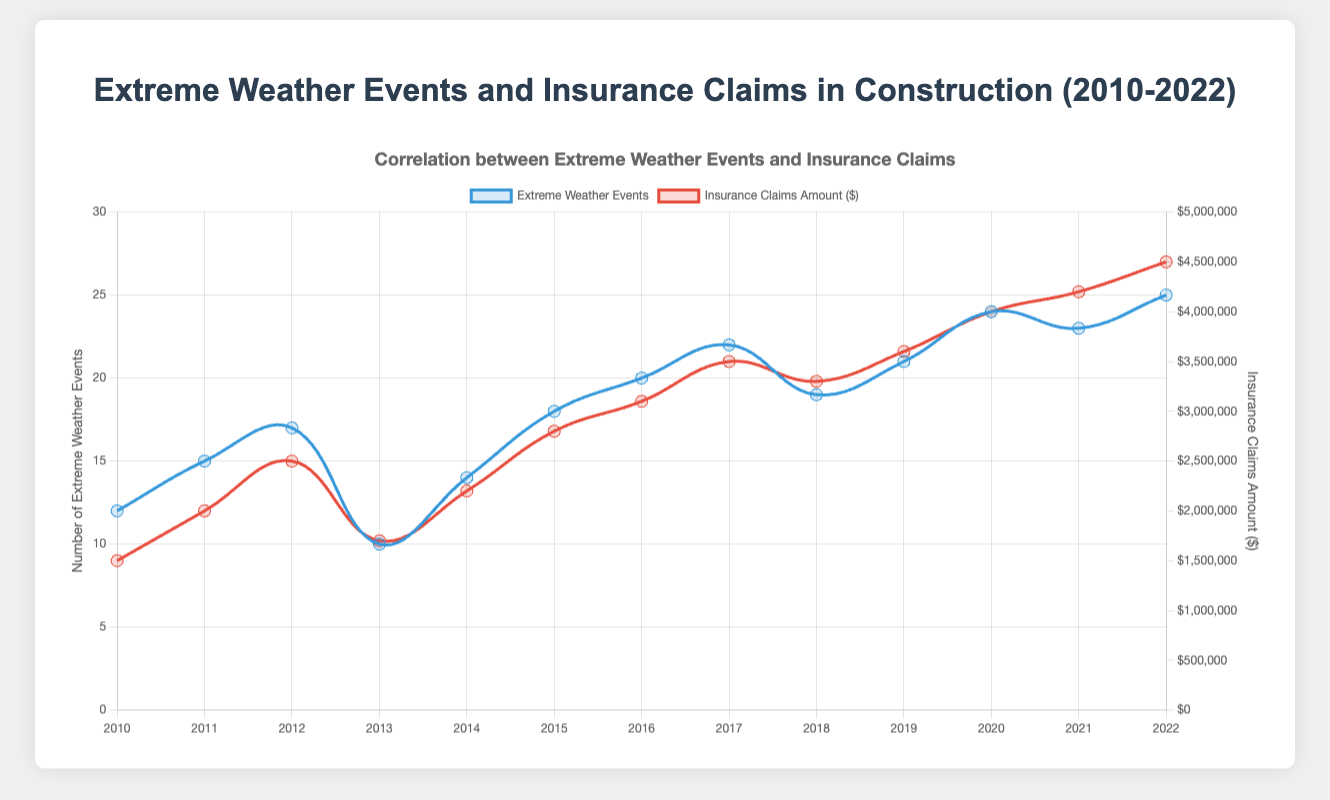What's the trend in insurance claim amounts from 2010 to 2022? To identify the trend, observe the red line in the plot corresponding to insurance claims. The claims amount generally increases from around $1,500,000 in 2010 to $4,500,000 in 2022.
Answer: Increasing In which year did the number of extreme weather events see the highest increase compared to the previous year? Look for the year with the steepest upward slope in the blue line representing extreme weather events. From 2012 to 2013, the number of events went from 17 to 10, showing a decrease. However, the highest increase is from 2019 to 2020, where the number of events increased from 21 to 24.
Answer: 2019 to 2020 What is the average number of extreme weather events between 2010 and 2012? Sum the number of extreme weather events for 2010, 2011, and 2012, then divide by the number of years. (12 + 15 + 17) / 3 = 44 / 3 ≈ 14.67
Answer: 14.67 Compare the insurance claims amount in 2013 and 2015. Which year had a higher amount? Refer to the red line and find the insurance claims amounts for 2013 and 2015. In 2013, it is $1,700,000, and in 2015, it is $2,800,000.
Answer: 2015 Which year had the lowest number of extreme weather events? Identify the minimum point on the blue line. The lowest point corresponds to the year 2013 with 10 events.
Answer: 2013 What was the difference in insurance claims amount between 2016 and 2020? Subtract the insurance claims amount in 2016 from that in 2020: $4,000,000 - $3,100,000 = $900,000.
Answer: $900,000 What was the total insurance claims amount from 2018 to 2020? Sum the insurance claims amounts from 2018, 2019, and 2020: $3,300,000 + $3,600,000 + $4,000,000 = $10,900,000.
Answer: $10,900,000 Between which two consecutive years did the number of extreme weather events remain the closest? Compare the differences in extreme weather events between consecutive years. The closest difference is between 2021 (23 events) and 2022 (25 events), a difference of 2 events.
Answer: 2021 and 2022 Does there appear to be a correlation between extreme weather events and insurance claims amounts? Analyze the overall trends of both the blue and red lines. Both lines show an increasing trend, implying a positive correlation where more extreme weather events tend to result in higher insurance claims amounts.
Answer: Yes What is the ratio of extreme weather events to insurance claims amount for 2021? Calculate the ratio by dividing the number of extreme weather events by the insurance claims amount. For 2021: 23 events / $4,200,000 = 23 / 4200000 ≈ 0.00000548 events per dollar.
Answer: 0.00000548 